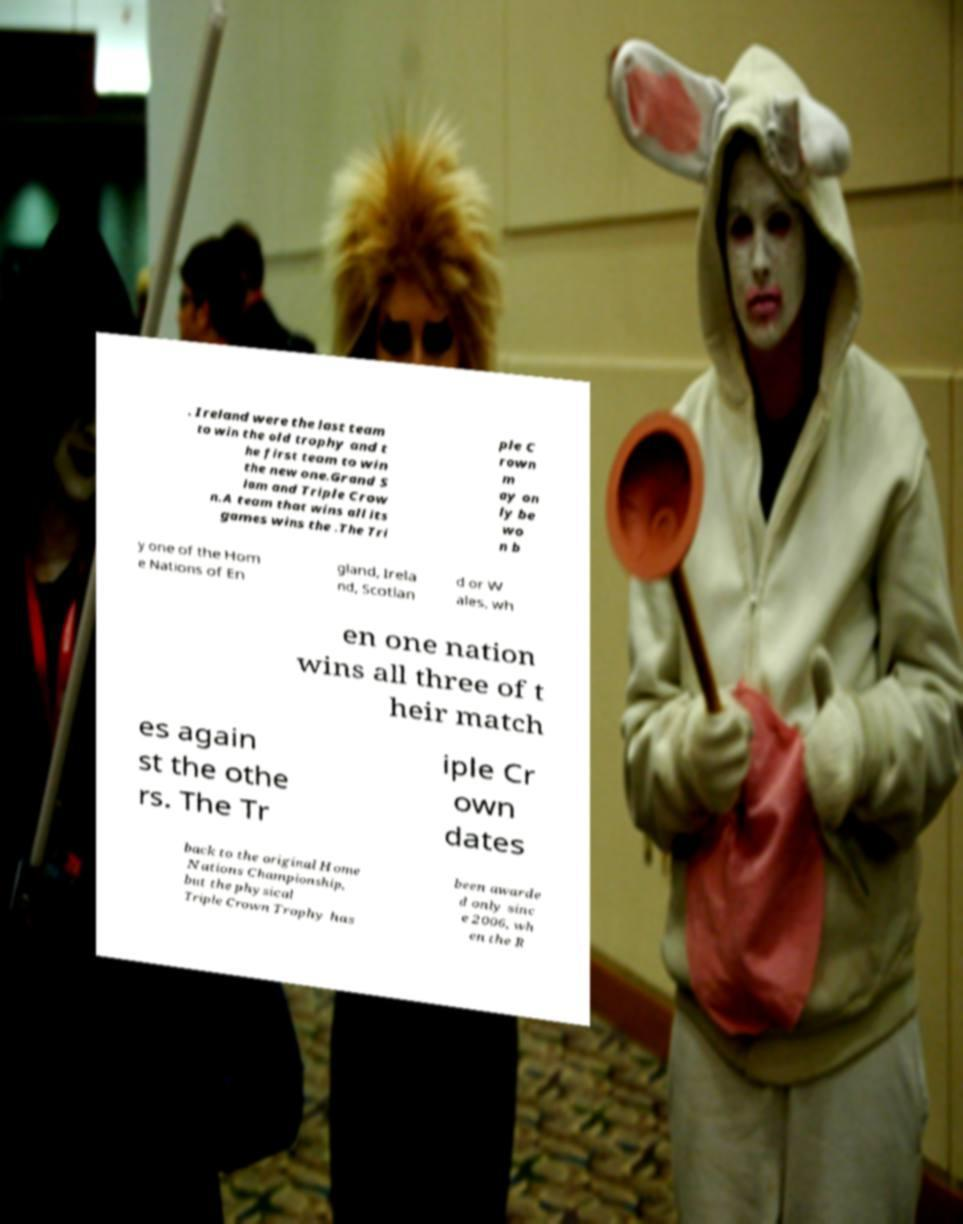I need the written content from this picture converted into text. Can you do that? . Ireland were the last team to win the old trophy and t he first team to win the new one.Grand S lam and Triple Crow n.A team that wins all its games wins the .The Tri ple C rown m ay on ly be wo n b y one of the Hom e Nations of En gland, Irela nd, Scotlan d or W ales, wh en one nation wins all three of t heir match es again st the othe rs. The Tr iple Cr own dates back to the original Home Nations Championship, but the physical Triple Crown Trophy has been awarde d only sinc e 2006, wh en the R 